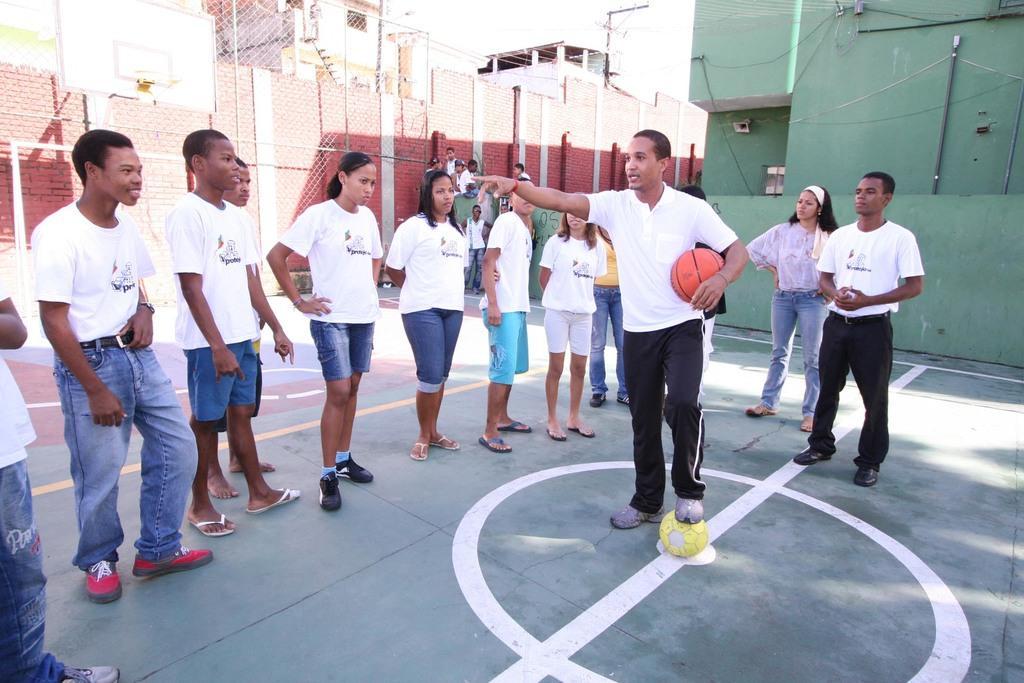In one or two sentences, can you explain what this image depicts? In this image we can see people standing on the ground and one of them is holding balls with hand and leg on the floor. In the background there are buildings, pipelines, fences, electric poles and sky. 